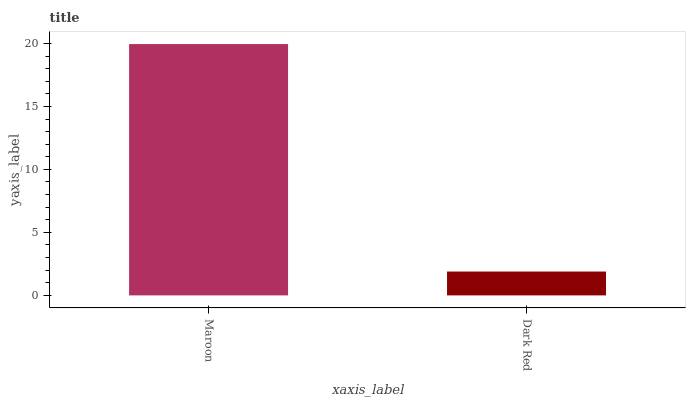Is Dark Red the maximum?
Answer yes or no. No. Is Maroon greater than Dark Red?
Answer yes or no. Yes. Is Dark Red less than Maroon?
Answer yes or no. Yes. Is Dark Red greater than Maroon?
Answer yes or no. No. Is Maroon less than Dark Red?
Answer yes or no. No. Is Maroon the high median?
Answer yes or no. Yes. Is Dark Red the low median?
Answer yes or no. Yes. Is Dark Red the high median?
Answer yes or no. No. Is Maroon the low median?
Answer yes or no. No. 